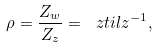<formula> <loc_0><loc_0><loc_500><loc_500>\rho = \frac { Z _ { w } } { Z _ { z } } = \ z t i l { z } ^ { - 1 } ,</formula> 